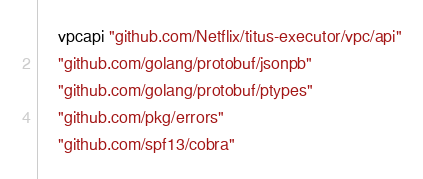Convert code to text. <code><loc_0><loc_0><loc_500><loc_500><_Go_>
	vpcapi "github.com/Netflix/titus-executor/vpc/api"
	"github.com/golang/protobuf/jsonpb"
	"github.com/golang/protobuf/ptypes"
	"github.com/pkg/errors"
	"github.com/spf13/cobra"</code> 